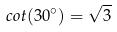Convert formula to latex. <formula><loc_0><loc_0><loc_500><loc_500>c o t ( 3 0 ^ { \circ } ) = \sqrt { 3 }</formula> 